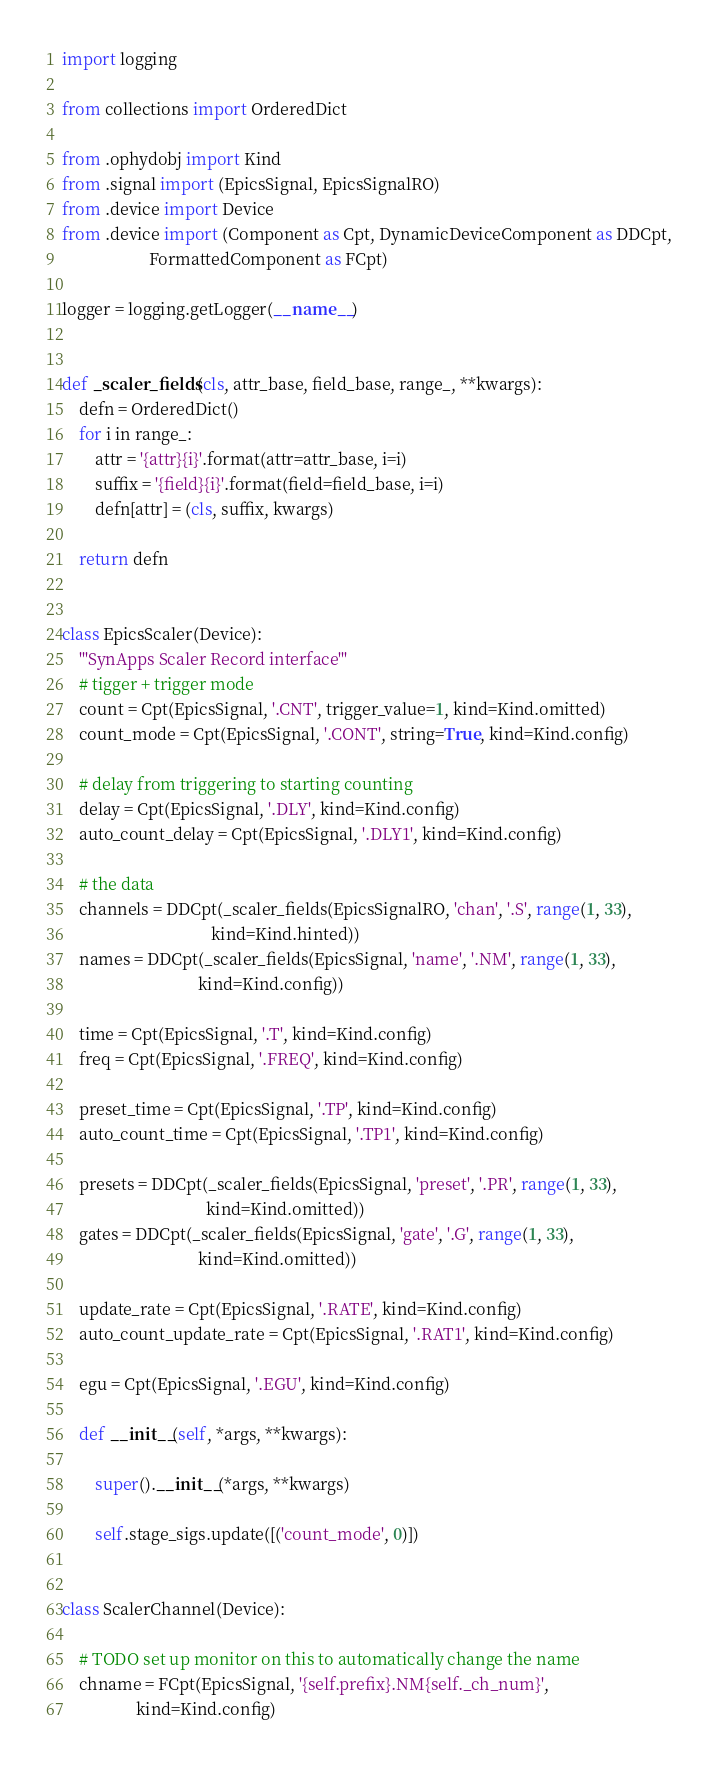<code> <loc_0><loc_0><loc_500><loc_500><_Python_>import logging

from collections import OrderedDict

from .ophydobj import Kind
from .signal import (EpicsSignal, EpicsSignalRO)
from .device import Device
from .device import (Component as Cpt, DynamicDeviceComponent as DDCpt,
                     FormattedComponent as FCpt)

logger = logging.getLogger(__name__)


def _scaler_fields(cls, attr_base, field_base, range_, **kwargs):
    defn = OrderedDict()
    for i in range_:
        attr = '{attr}{i}'.format(attr=attr_base, i=i)
        suffix = '{field}{i}'.format(field=field_base, i=i)
        defn[attr] = (cls, suffix, kwargs)

    return defn


class EpicsScaler(Device):
    '''SynApps Scaler Record interface'''
    # tigger + trigger mode
    count = Cpt(EpicsSignal, '.CNT', trigger_value=1, kind=Kind.omitted)
    count_mode = Cpt(EpicsSignal, '.CONT', string=True, kind=Kind.config)

    # delay from triggering to starting counting
    delay = Cpt(EpicsSignal, '.DLY', kind=Kind.config)
    auto_count_delay = Cpt(EpicsSignal, '.DLY1', kind=Kind.config)

    # the data
    channels = DDCpt(_scaler_fields(EpicsSignalRO, 'chan', '.S', range(1, 33),
                                    kind=Kind.hinted))
    names = DDCpt(_scaler_fields(EpicsSignal, 'name', '.NM', range(1, 33),
                                 kind=Kind.config))

    time = Cpt(EpicsSignal, '.T', kind=Kind.config)
    freq = Cpt(EpicsSignal, '.FREQ', kind=Kind.config)

    preset_time = Cpt(EpicsSignal, '.TP', kind=Kind.config)
    auto_count_time = Cpt(EpicsSignal, '.TP1', kind=Kind.config)

    presets = DDCpt(_scaler_fields(EpicsSignal, 'preset', '.PR', range(1, 33),
                                   kind=Kind.omitted))
    gates = DDCpt(_scaler_fields(EpicsSignal, 'gate', '.G', range(1, 33),
                                 kind=Kind.omitted))

    update_rate = Cpt(EpicsSignal, '.RATE', kind=Kind.config)
    auto_count_update_rate = Cpt(EpicsSignal, '.RAT1', kind=Kind.config)

    egu = Cpt(EpicsSignal, '.EGU', kind=Kind.config)

    def __init__(self, *args, **kwargs):

        super().__init__(*args, **kwargs)

        self.stage_sigs.update([('count_mode', 0)])


class ScalerChannel(Device):

    # TODO set up monitor on this to automatically change the name
    chname = FCpt(EpicsSignal, '{self.prefix}.NM{self._ch_num}',
                  kind=Kind.config)</code> 